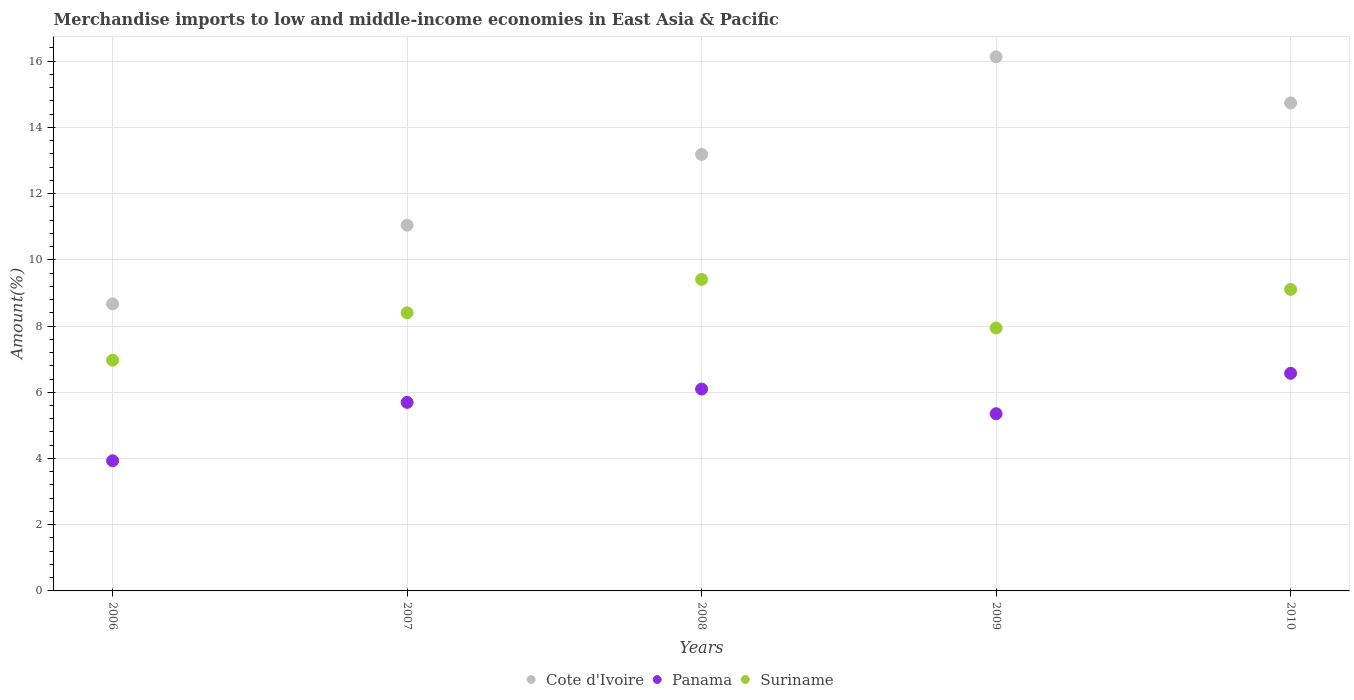How many different coloured dotlines are there?
Provide a succinct answer. 3. What is the percentage of amount earned from merchandise imports in Suriname in 2006?
Ensure brevity in your answer.  6.97. Across all years, what is the maximum percentage of amount earned from merchandise imports in Cote d'Ivoire?
Offer a terse response. 16.13. Across all years, what is the minimum percentage of amount earned from merchandise imports in Suriname?
Offer a very short reply. 6.97. What is the total percentage of amount earned from merchandise imports in Cote d'Ivoire in the graph?
Provide a short and direct response. 63.77. What is the difference between the percentage of amount earned from merchandise imports in Suriname in 2007 and that in 2009?
Ensure brevity in your answer.  0.46. What is the difference between the percentage of amount earned from merchandise imports in Panama in 2007 and the percentage of amount earned from merchandise imports in Cote d'Ivoire in 2010?
Your response must be concise. -9.04. What is the average percentage of amount earned from merchandise imports in Cote d'Ivoire per year?
Provide a short and direct response. 12.75. In the year 2009, what is the difference between the percentage of amount earned from merchandise imports in Cote d'Ivoire and percentage of amount earned from merchandise imports in Suriname?
Provide a short and direct response. 8.19. What is the ratio of the percentage of amount earned from merchandise imports in Panama in 2006 to that in 2007?
Your answer should be compact. 0.69. What is the difference between the highest and the second highest percentage of amount earned from merchandise imports in Cote d'Ivoire?
Provide a short and direct response. 1.4. What is the difference between the highest and the lowest percentage of amount earned from merchandise imports in Cote d'Ivoire?
Your answer should be very brief. 7.46. In how many years, is the percentage of amount earned from merchandise imports in Panama greater than the average percentage of amount earned from merchandise imports in Panama taken over all years?
Keep it short and to the point. 3. Is it the case that in every year, the sum of the percentage of amount earned from merchandise imports in Suriname and percentage of amount earned from merchandise imports in Cote d'Ivoire  is greater than the percentage of amount earned from merchandise imports in Panama?
Offer a very short reply. Yes. Is the percentage of amount earned from merchandise imports in Suriname strictly less than the percentage of amount earned from merchandise imports in Panama over the years?
Provide a succinct answer. No. What is the difference between two consecutive major ticks on the Y-axis?
Provide a short and direct response. 2. Does the graph contain any zero values?
Your answer should be compact. No. Does the graph contain grids?
Offer a very short reply. Yes. Where does the legend appear in the graph?
Ensure brevity in your answer.  Bottom center. What is the title of the graph?
Keep it short and to the point. Merchandise imports to low and middle-income economies in East Asia & Pacific. What is the label or title of the Y-axis?
Provide a short and direct response. Amount(%). What is the Amount(%) in Cote d'Ivoire in 2006?
Your response must be concise. 8.67. What is the Amount(%) in Panama in 2006?
Ensure brevity in your answer.  3.93. What is the Amount(%) of Suriname in 2006?
Offer a terse response. 6.97. What is the Amount(%) of Cote d'Ivoire in 2007?
Ensure brevity in your answer.  11.05. What is the Amount(%) in Panama in 2007?
Ensure brevity in your answer.  5.69. What is the Amount(%) in Suriname in 2007?
Offer a terse response. 8.4. What is the Amount(%) of Cote d'Ivoire in 2008?
Offer a very short reply. 13.18. What is the Amount(%) of Panama in 2008?
Make the answer very short. 6.1. What is the Amount(%) in Suriname in 2008?
Make the answer very short. 9.41. What is the Amount(%) in Cote d'Ivoire in 2009?
Provide a succinct answer. 16.13. What is the Amount(%) of Panama in 2009?
Ensure brevity in your answer.  5.35. What is the Amount(%) in Suriname in 2009?
Give a very brief answer. 7.94. What is the Amount(%) of Cote d'Ivoire in 2010?
Offer a very short reply. 14.74. What is the Amount(%) of Panama in 2010?
Your response must be concise. 6.57. What is the Amount(%) in Suriname in 2010?
Provide a succinct answer. 9.11. Across all years, what is the maximum Amount(%) of Cote d'Ivoire?
Offer a terse response. 16.13. Across all years, what is the maximum Amount(%) in Panama?
Keep it short and to the point. 6.57. Across all years, what is the maximum Amount(%) of Suriname?
Make the answer very short. 9.41. Across all years, what is the minimum Amount(%) of Cote d'Ivoire?
Offer a very short reply. 8.67. Across all years, what is the minimum Amount(%) of Panama?
Give a very brief answer. 3.93. Across all years, what is the minimum Amount(%) of Suriname?
Keep it short and to the point. 6.97. What is the total Amount(%) of Cote d'Ivoire in the graph?
Make the answer very short. 63.77. What is the total Amount(%) of Panama in the graph?
Offer a very short reply. 27.65. What is the total Amount(%) of Suriname in the graph?
Give a very brief answer. 41.82. What is the difference between the Amount(%) in Cote d'Ivoire in 2006 and that in 2007?
Provide a succinct answer. -2.38. What is the difference between the Amount(%) in Panama in 2006 and that in 2007?
Offer a terse response. -1.76. What is the difference between the Amount(%) of Suriname in 2006 and that in 2007?
Give a very brief answer. -1.43. What is the difference between the Amount(%) in Cote d'Ivoire in 2006 and that in 2008?
Offer a terse response. -4.52. What is the difference between the Amount(%) of Panama in 2006 and that in 2008?
Make the answer very short. -2.17. What is the difference between the Amount(%) in Suriname in 2006 and that in 2008?
Provide a succinct answer. -2.44. What is the difference between the Amount(%) of Cote d'Ivoire in 2006 and that in 2009?
Provide a short and direct response. -7.46. What is the difference between the Amount(%) in Panama in 2006 and that in 2009?
Provide a succinct answer. -1.42. What is the difference between the Amount(%) of Suriname in 2006 and that in 2009?
Keep it short and to the point. -0.97. What is the difference between the Amount(%) of Cote d'Ivoire in 2006 and that in 2010?
Offer a terse response. -6.07. What is the difference between the Amount(%) of Panama in 2006 and that in 2010?
Keep it short and to the point. -2.64. What is the difference between the Amount(%) of Suriname in 2006 and that in 2010?
Offer a very short reply. -2.14. What is the difference between the Amount(%) of Cote d'Ivoire in 2007 and that in 2008?
Give a very brief answer. -2.14. What is the difference between the Amount(%) of Panama in 2007 and that in 2008?
Give a very brief answer. -0.4. What is the difference between the Amount(%) in Suriname in 2007 and that in 2008?
Offer a terse response. -1.01. What is the difference between the Amount(%) of Cote d'Ivoire in 2007 and that in 2009?
Provide a short and direct response. -5.09. What is the difference between the Amount(%) of Panama in 2007 and that in 2009?
Give a very brief answer. 0.34. What is the difference between the Amount(%) in Suriname in 2007 and that in 2009?
Your answer should be compact. 0.46. What is the difference between the Amount(%) of Cote d'Ivoire in 2007 and that in 2010?
Ensure brevity in your answer.  -3.69. What is the difference between the Amount(%) of Panama in 2007 and that in 2010?
Your answer should be compact. -0.88. What is the difference between the Amount(%) of Suriname in 2007 and that in 2010?
Your response must be concise. -0.7. What is the difference between the Amount(%) in Cote d'Ivoire in 2008 and that in 2009?
Provide a succinct answer. -2.95. What is the difference between the Amount(%) of Panama in 2008 and that in 2009?
Provide a succinct answer. 0.75. What is the difference between the Amount(%) in Suriname in 2008 and that in 2009?
Offer a very short reply. 1.47. What is the difference between the Amount(%) of Cote d'Ivoire in 2008 and that in 2010?
Offer a very short reply. -1.55. What is the difference between the Amount(%) of Panama in 2008 and that in 2010?
Your answer should be very brief. -0.48. What is the difference between the Amount(%) of Suriname in 2008 and that in 2010?
Give a very brief answer. 0.3. What is the difference between the Amount(%) of Cote d'Ivoire in 2009 and that in 2010?
Provide a succinct answer. 1.4. What is the difference between the Amount(%) in Panama in 2009 and that in 2010?
Provide a succinct answer. -1.22. What is the difference between the Amount(%) in Suriname in 2009 and that in 2010?
Offer a very short reply. -1.16. What is the difference between the Amount(%) in Cote d'Ivoire in 2006 and the Amount(%) in Panama in 2007?
Make the answer very short. 2.97. What is the difference between the Amount(%) of Cote d'Ivoire in 2006 and the Amount(%) of Suriname in 2007?
Keep it short and to the point. 0.27. What is the difference between the Amount(%) in Panama in 2006 and the Amount(%) in Suriname in 2007?
Your answer should be very brief. -4.47. What is the difference between the Amount(%) in Cote d'Ivoire in 2006 and the Amount(%) in Panama in 2008?
Keep it short and to the point. 2.57. What is the difference between the Amount(%) of Cote d'Ivoire in 2006 and the Amount(%) of Suriname in 2008?
Ensure brevity in your answer.  -0.74. What is the difference between the Amount(%) of Panama in 2006 and the Amount(%) of Suriname in 2008?
Offer a terse response. -5.48. What is the difference between the Amount(%) of Cote d'Ivoire in 2006 and the Amount(%) of Panama in 2009?
Ensure brevity in your answer.  3.32. What is the difference between the Amount(%) of Cote d'Ivoire in 2006 and the Amount(%) of Suriname in 2009?
Provide a short and direct response. 0.73. What is the difference between the Amount(%) of Panama in 2006 and the Amount(%) of Suriname in 2009?
Give a very brief answer. -4.01. What is the difference between the Amount(%) of Cote d'Ivoire in 2006 and the Amount(%) of Panama in 2010?
Make the answer very short. 2.1. What is the difference between the Amount(%) of Cote d'Ivoire in 2006 and the Amount(%) of Suriname in 2010?
Your answer should be very brief. -0.44. What is the difference between the Amount(%) in Panama in 2006 and the Amount(%) in Suriname in 2010?
Your answer should be compact. -5.17. What is the difference between the Amount(%) in Cote d'Ivoire in 2007 and the Amount(%) in Panama in 2008?
Offer a terse response. 4.95. What is the difference between the Amount(%) of Cote d'Ivoire in 2007 and the Amount(%) of Suriname in 2008?
Offer a very short reply. 1.64. What is the difference between the Amount(%) of Panama in 2007 and the Amount(%) of Suriname in 2008?
Offer a terse response. -3.71. What is the difference between the Amount(%) of Cote d'Ivoire in 2007 and the Amount(%) of Panama in 2009?
Ensure brevity in your answer.  5.69. What is the difference between the Amount(%) in Cote d'Ivoire in 2007 and the Amount(%) in Suriname in 2009?
Your answer should be compact. 3.1. What is the difference between the Amount(%) in Panama in 2007 and the Amount(%) in Suriname in 2009?
Provide a succinct answer. -2.25. What is the difference between the Amount(%) of Cote d'Ivoire in 2007 and the Amount(%) of Panama in 2010?
Offer a terse response. 4.47. What is the difference between the Amount(%) in Cote d'Ivoire in 2007 and the Amount(%) in Suriname in 2010?
Give a very brief answer. 1.94. What is the difference between the Amount(%) of Panama in 2007 and the Amount(%) of Suriname in 2010?
Give a very brief answer. -3.41. What is the difference between the Amount(%) of Cote d'Ivoire in 2008 and the Amount(%) of Panama in 2009?
Make the answer very short. 7.83. What is the difference between the Amount(%) in Cote d'Ivoire in 2008 and the Amount(%) in Suriname in 2009?
Provide a short and direct response. 5.24. What is the difference between the Amount(%) of Panama in 2008 and the Amount(%) of Suriname in 2009?
Ensure brevity in your answer.  -1.84. What is the difference between the Amount(%) in Cote d'Ivoire in 2008 and the Amount(%) in Panama in 2010?
Offer a very short reply. 6.61. What is the difference between the Amount(%) of Cote d'Ivoire in 2008 and the Amount(%) of Suriname in 2010?
Offer a very short reply. 4.08. What is the difference between the Amount(%) of Panama in 2008 and the Amount(%) of Suriname in 2010?
Offer a very short reply. -3.01. What is the difference between the Amount(%) of Cote d'Ivoire in 2009 and the Amount(%) of Panama in 2010?
Your answer should be very brief. 9.56. What is the difference between the Amount(%) in Cote d'Ivoire in 2009 and the Amount(%) in Suriname in 2010?
Provide a short and direct response. 7.03. What is the difference between the Amount(%) of Panama in 2009 and the Amount(%) of Suriname in 2010?
Ensure brevity in your answer.  -3.75. What is the average Amount(%) of Cote d'Ivoire per year?
Make the answer very short. 12.75. What is the average Amount(%) in Panama per year?
Provide a short and direct response. 5.53. What is the average Amount(%) in Suriname per year?
Give a very brief answer. 8.36. In the year 2006, what is the difference between the Amount(%) in Cote d'Ivoire and Amount(%) in Panama?
Provide a succinct answer. 4.74. In the year 2006, what is the difference between the Amount(%) in Cote d'Ivoire and Amount(%) in Suriname?
Provide a short and direct response. 1.7. In the year 2006, what is the difference between the Amount(%) in Panama and Amount(%) in Suriname?
Make the answer very short. -3.04. In the year 2007, what is the difference between the Amount(%) in Cote d'Ivoire and Amount(%) in Panama?
Your response must be concise. 5.35. In the year 2007, what is the difference between the Amount(%) in Cote d'Ivoire and Amount(%) in Suriname?
Provide a succinct answer. 2.64. In the year 2007, what is the difference between the Amount(%) in Panama and Amount(%) in Suriname?
Offer a very short reply. -2.71. In the year 2008, what is the difference between the Amount(%) in Cote d'Ivoire and Amount(%) in Panama?
Your response must be concise. 7.09. In the year 2008, what is the difference between the Amount(%) in Cote d'Ivoire and Amount(%) in Suriname?
Offer a terse response. 3.78. In the year 2008, what is the difference between the Amount(%) of Panama and Amount(%) of Suriname?
Make the answer very short. -3.31. In the year 2009, what is the difference between the Amount(%) of Cote d'Ivoire and Amount(%) of Panama?
Offer a very short reply. 10.78. In the year 2009, what is the difference between the Amount(%) in Cote d'Ivoire and Amount(%) in Suriname?
Provide a succinct answer. 8.19. In the year 2009, what is the difference between the Amount(%) of Panama and Amount(%) of Suriname?
Make the answer very short. -2.59. In the year 2010, what is the difference between the Amount(%) of Cote d'Ivoire and Amount(%) of Panama?
Offer a terse response. 8.16. In the year 2010, what is the difference between the Amount(%) of Cote d'Ivoire and Amount(%) of Suriname?
Provide a short and direct response. 5.63. In the year 2010, what is the difference between the Amount(%) of Panama and Amount(%) of Suriname?
Offer a terse response. -2.53. What is the ratio of the Amount(%) of Cote d'Ivoire in 2006 to that in 2007?
Your answer should be compact. 0.78. What is the ratio of the Amount(%) of Panama in 2006 to that in 2007?
Your answer should be compact. 0.69. What is the ratio of the Amount(%) of Suriname in 2006 to that in 2007?
Your response must be concise. 0.83. What is the ratio of the Amount(%) of Cote d'Ivoire in 2006 to that in 2008?
Ensure brevity in your answer.  0.66. What is the ratio of the Amount(%) in Panama in 2006 to that in 2008?
Provide a succinct answer. 0.64. What is the ratio of the Amount(%) in Suriname in 2006 to that in 2008?
Your answer should be compact. 0.74. What is the ratio of the Amount(%) of Cote d'Ivoire in 2006 to that in 2009?
Provide a succinct answer. 0.54. What is the ratio of the Amount(%) of Panama in 2006 to that in 2009?
Provide a short and direct response. 0.73. What is the ratio of the Amount(%) in Suriname in 2006 to that in 2009?
Give a very brief answer. 0.88. What is the ratio of the Amount(%) of Cote d'Ivoire in 2006 to that in 2010?
Give a very brief answer. 0.59. What is the ratio of the Amount(%) in Panama in 2006 to that in 2010?
Ensure brevity in your answer.  0.6. What is the ratio of the Amount(%) of Suriname in 2006 to that in 2010?
Your response must be concise. 0.77. What is the ratio of the Amount(%) of Cote d'Ivoire in 2007 to that in 2008?
Provide a short and direct response. 0.84. What is the ratio of the Amount(%) of Panama in 2007 to that in 2008?
Your answer should be compact. 0.93. What is the ratio of the Amount(%) of Suriname in 2007 to that in 2008?
Give a very brief answer. 0.89. What is the ratio of the Amount(%) of Cote d'Ivoire in 2007 to that in 2009?
Provide a succinct answer. 0.68. What is the ratio of the Amount(%) in Panama in 2007 to that in 2009?
Provide a short and direct response. 1.06. What is the ratio of the Amount(%) in Suriname in 2007 to that in 2009?
Give a very brief answer. 1.06. What is the ratio of the Amount(%) in Cote d'Ivoire in 2007 to that in 2010?
Make the answer very short. 0.75. What is the ratio of the Amount(%) in Panama in 2007 to that in 2010?
Your answer should be very brief. 0.87. What is the ratio of the Amount(%) of Suriname in 2007 to that in 2010?
Your answer should be very brief. 0.92. What is the ratio of the Amount(%) of Cote d'Ivoire in 2008 to that in 2009?
Provide a short and direct response. 0.82. What is the ratio of the Amount(%) of Panama in 2008 to that in 2009?
Give a very brief answer. 1.14. What is the ratio of the Amount(%) in Suriname in 2008 to that in 2009?
Your answer should be compact. 1.18. What is the ratio of the Amount(%) in Cote d'Ivoire in 2008 to that in 2010?
Your answer should be very brief. 0.89. What is the ratio of the Amount(%) of Panama in 2008 to that in 2010?
Keep it short and to the point. 0.93. What is the ratio of the Amount(%) of Cote d'Ivoire in 2009 to that in 2010?
Your answer should be compact. 1.09. What is the ratio of the Amount(%) of Panama in 2009 to that in 2010?
Your answer should be very brief. 0.81. What is the ratio of the Amount(%) in Suriname in 2009 to that in 2010?
Your response must be concise. 0.87. What is the difference between the highest and the second highest Amount(%) of Cote d'Ivoire?
Your answer should be compact. 1.4. What is the difference between the highest and the second highest Amount(%) of Panama?
Your response must be concise. 0.48. What is the difference between the highest and the second highest Amount(%) of Suriname?
Make the answer very short. 0.3. What is the difference between the highest and the lowest Amount(%) of Cote d'Ivoire?
Provide a succinct answer. 7.46. What is the difference between the highest and the lowest Amount(%) in Panama?
Offer a terse response. 2.64. What is the difference between the highest and the lowest Amount(%) of Suriname?
Offer a terse response. 2.44. 